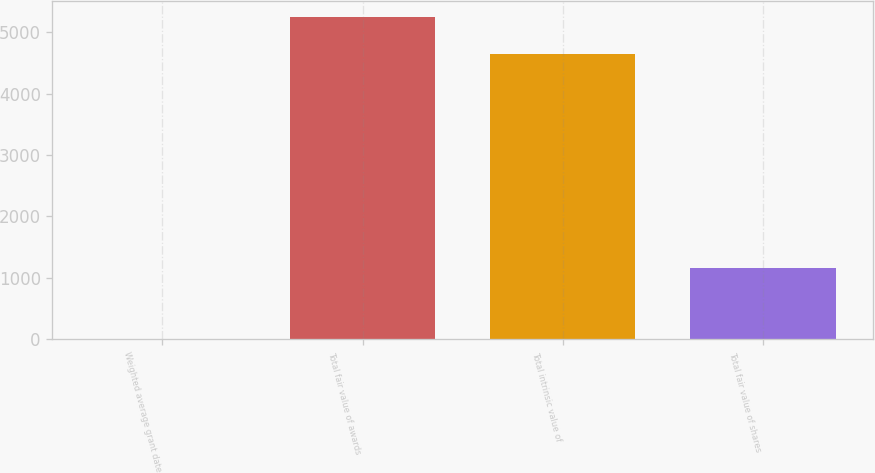Convert chart. <chart><loc_0><loc_0><loc_500><loc_500><bar_chart><fcel>Weighted average grant date<fcel>Total fair value of awards<fcel>Total intrinsic value of<fcel>Total fair value of shares<nl><fcel>5.92<fcel>5250.91<fcel>4642<fcel>1169<nl></chart> 